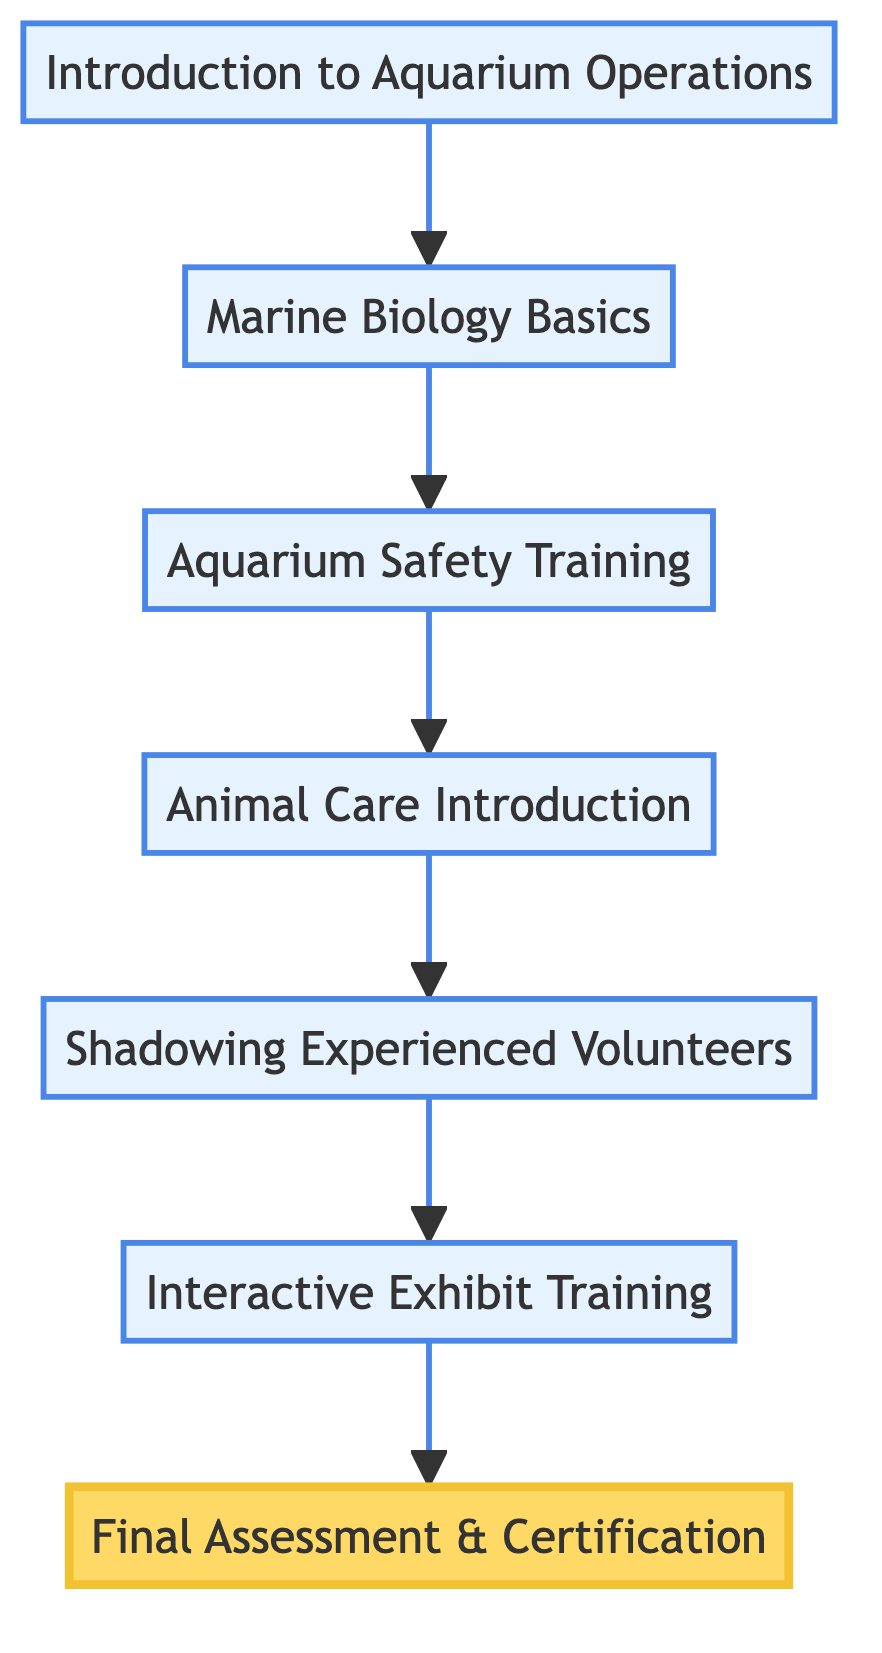What is the first step in the training process? The first step in the training process is found at the bottom of the diagram, which starts with "Introduction to Aquarium Operations."
Answer: Introduction to Aquarium Operations How many steps are there in total? There are seven distinct steps in the training process as displayed by the nodes in the flowchart.
Answer: 7 What comes after "Aquarium Safety Training"? To find what comes after "Aquarium Safety Training," follow the arrow that leads to "Animal Care Introduction."
Answer: Animal Care Introduction What is the final node of the training process? The final node is at the top of the diagram and is labeled "Final Assessment & Certification."
Answer: Final Assessment & Certification Which step involves direct interaction with the public? The step that involves direct interaction with the public is labeled "Interactive Exhibit Training."
Answer: Interactive Exhibit Training What step precedes "Shadowing Experienced Volunteers"? To locate the step that precedes "Shadowing Experienced Volunteers," look at the flowchart, which shows that "Animal Care Introduction" comes before it.
Answer: Animal Care Introduction If a volunteer completes "Final Assessment & Certification," what is the previous step they must have completed? The flowchart indicates that the previous step before "Final Assessment & Certification" is "Interactive Exhibit Training," as it flows directly into the final step.
Answer: Interactive Exhibit Training What type of training involves safety procedures? The type of training that involves safety procedures is "Aquarium Safety Training."
Answer: Aquarium Safety Training What is the primary focus of the "Marine Biology Basics" step? The primary focus of "Marine Biology Basics" is to introduce key concepts such as marine ecosystems and species.
Answer: Marine Biology Concepts 